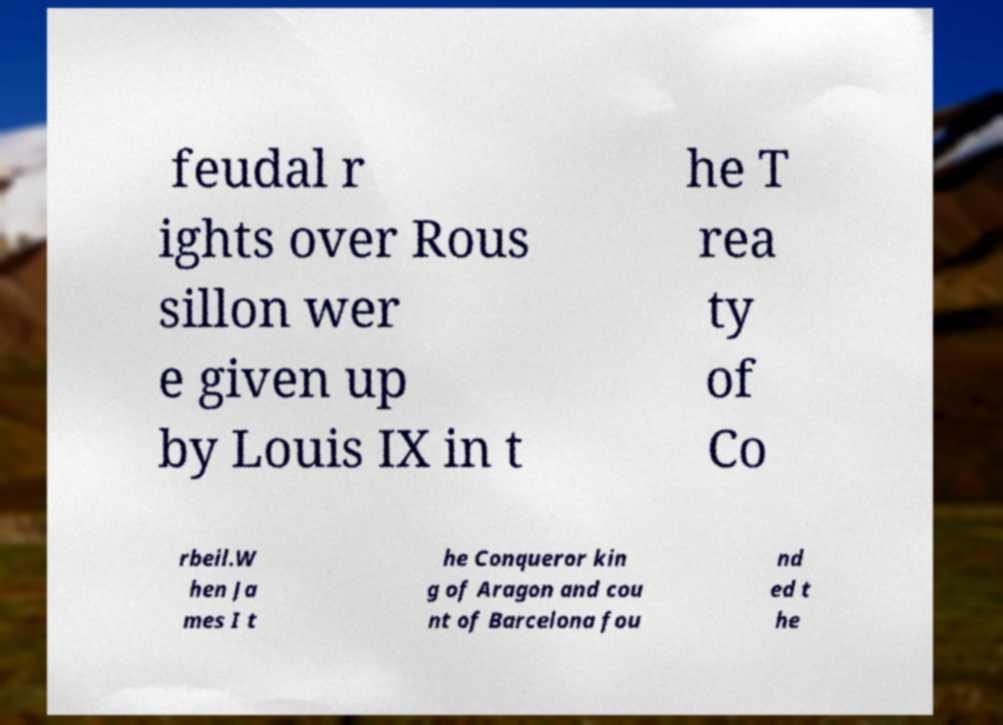Please read and relay the text visible in this image. What does it say? feudal r ights over Rous sillon wer e given up by Louis IX in t he T rea ty of Co rbeil.W hen Ja mes I t he Conqueror kin g of Aragon and cou nt of Barcelona fou nd ed t he 